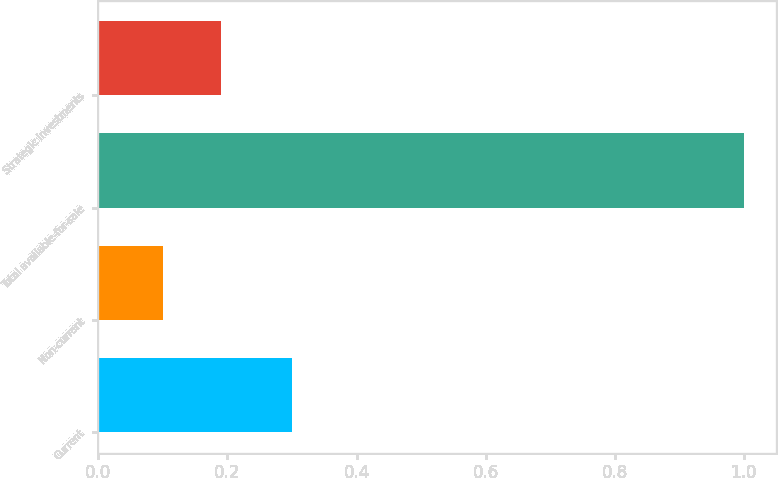<chart> <loc_0><loc_0><loc_500><loc_500><bar_chart><fcel>Current<fcel>Non-current<fcel>Total available-for-sale<fcel>Strategic investments<nl><fcel>0.3<fcel>0.1<fcel>1<fcel>0.19<nl></chart> 